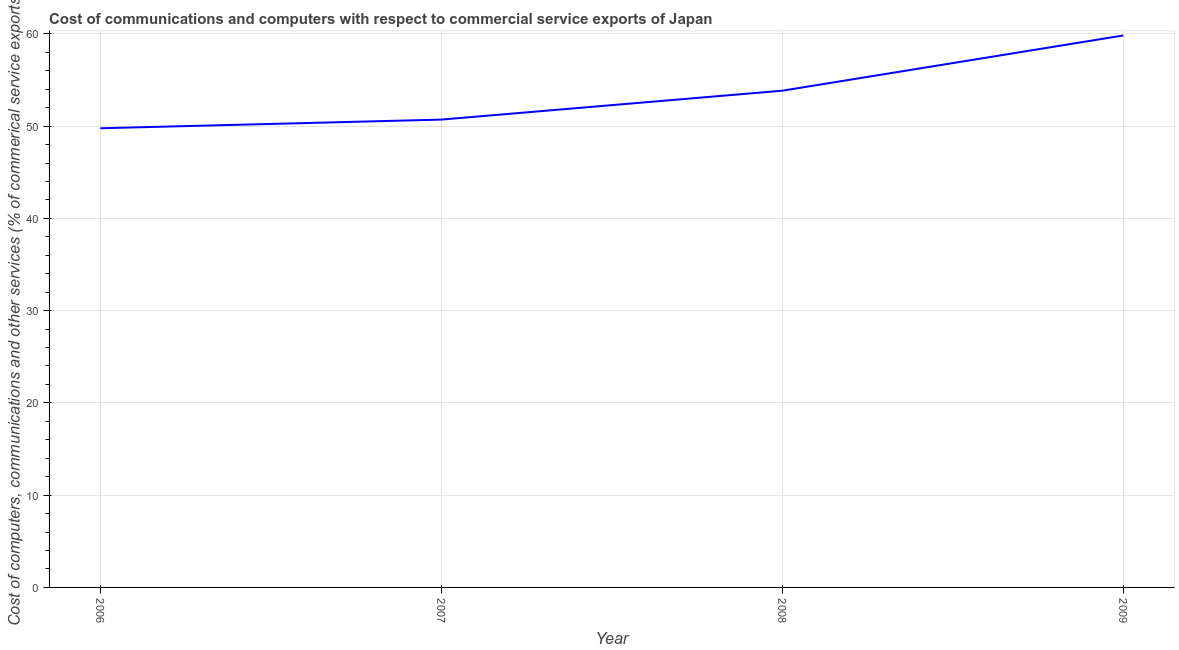What is the  computer and other services in 2007?
Give a very brief answer. 50.71. Across all years, what is the maximum cost of communications?
Offer a terse response. 59.83. Across all years, what is the minimum  computer and other services?
Keep it short and to the point. 49.77. In which year was the  computer and other services maximum?
Provide a succinct answer. 2009. What is the sum of the  computer and other services?
Keep it short and to the point. 214.14. What is the difference between the  computer and other services in 2008 and 2009?
Provide a succinct answer. -5.99. What is the average cost of communications per year?
Ensure brevity in your answer.  53.53. What is the median cost of communications?
Your answer should be very brief. 52.27. In how many years, is the cost of communications greater than 48 %?
Offer a very short reply. 4. Do a majority of the years between 2007 and 2008 (inclusive) have cost of communications greater than 56 %?
Provide a short and direct response. No. What is the ratio of the  computer and other services in 2006 to that in 2007?
Your answer should be very brief. 0.98. What is the difference between the highest and the second highest cost of communications?
Your answer should be very brief. 5.99. What is the difference between the highest and the lowest cost of communications?
Provide a succinct answer. 10.06. What is the difference between two consecutive major ticks on the Y-axis?
Give a very brief answer. 10. What is the title of the graph?
Your answer should be compact. Cost of communications and computers with respect to commercial service exports of Japan. What is the label or title of the X-axis?
Provide a short and direct response. Year. What is the label or title of the Y-axis?
Offer a terse response. Cost of computers, communications and other services (% of commerical service exports). What is the Cost of computers, communications and other services (% of commerical service exports) of 2006?
Ensure brevity in your answer.  49.77. What is the Cost of computers, communications and other services (% of commerical service exports) of 2007?
Make the answer very short. 50.71. What is the Cost of computers, communications and other services (% of commerical service exports) of 2008?
Keep it short and to the point. 53.84. What is the Cost of computers, communications and other services (% of commerical service exports) of 2009?
Keep it short and to the point. 59.83. What is the difference between the Cost of computers, communications and other services (% of commerical service exports) in 2006 and 2007?
Your answer should be compact. -0.94. What is the difference between the Cost of computers, communications and other services (% of commerical service exports) in 2006 and 2008?
Offer a very short reply. -4.07. What is the difference between the Cost of computers, communications and other services (% of commerical service exports) in 2006 and 2009?
Offer a very short reply. -10.06. What is the difference between the Cost of computers, communications and other services (% of commerical service exports) in 2007 and 2008?
Keep it short and to the point. -3.13. What is the difference between the Cost of computers, communications and other services (% of commerical service exports) in 2007 and 2009?
Your answer should be compact. -9.12. What is the difference between the Cost of computers, communications and other services (% of commerical service exports) in 2008 and 2009?
Provide a short and direct response. -5.99. What is the ratio of the Cost of computers, communications and other services (% of commerical service exports) in 2006 to that in 2008?
Make the answer very short. 0.92. What is the ratio of the Cost of computers, communications and other services (% of commerical service exports) in 2006 to that in 2009?
Offer a very short reply. 0.83. What is the ratio of the Cost of computers, communications and other services (% of commerical service exports) in 2007 to that in 2008?
Offer a very short reply. 0.94. What is the ratio of the Cost of computers, communications and other services (% of commerical service exports) in 2007 to that in 2009?
Offer a very short reply. 0.85. 